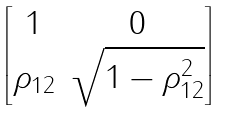<formula> <loc_0><loc_0><loc_500><loc_500>\begin{bmatrix} 1 & 0 \\ \rho _ { 1 2 } & \sqrt { 1 - \rho _ { 1 2 } ^ { 2 } } \\ \end{bmatrix}</formula> 